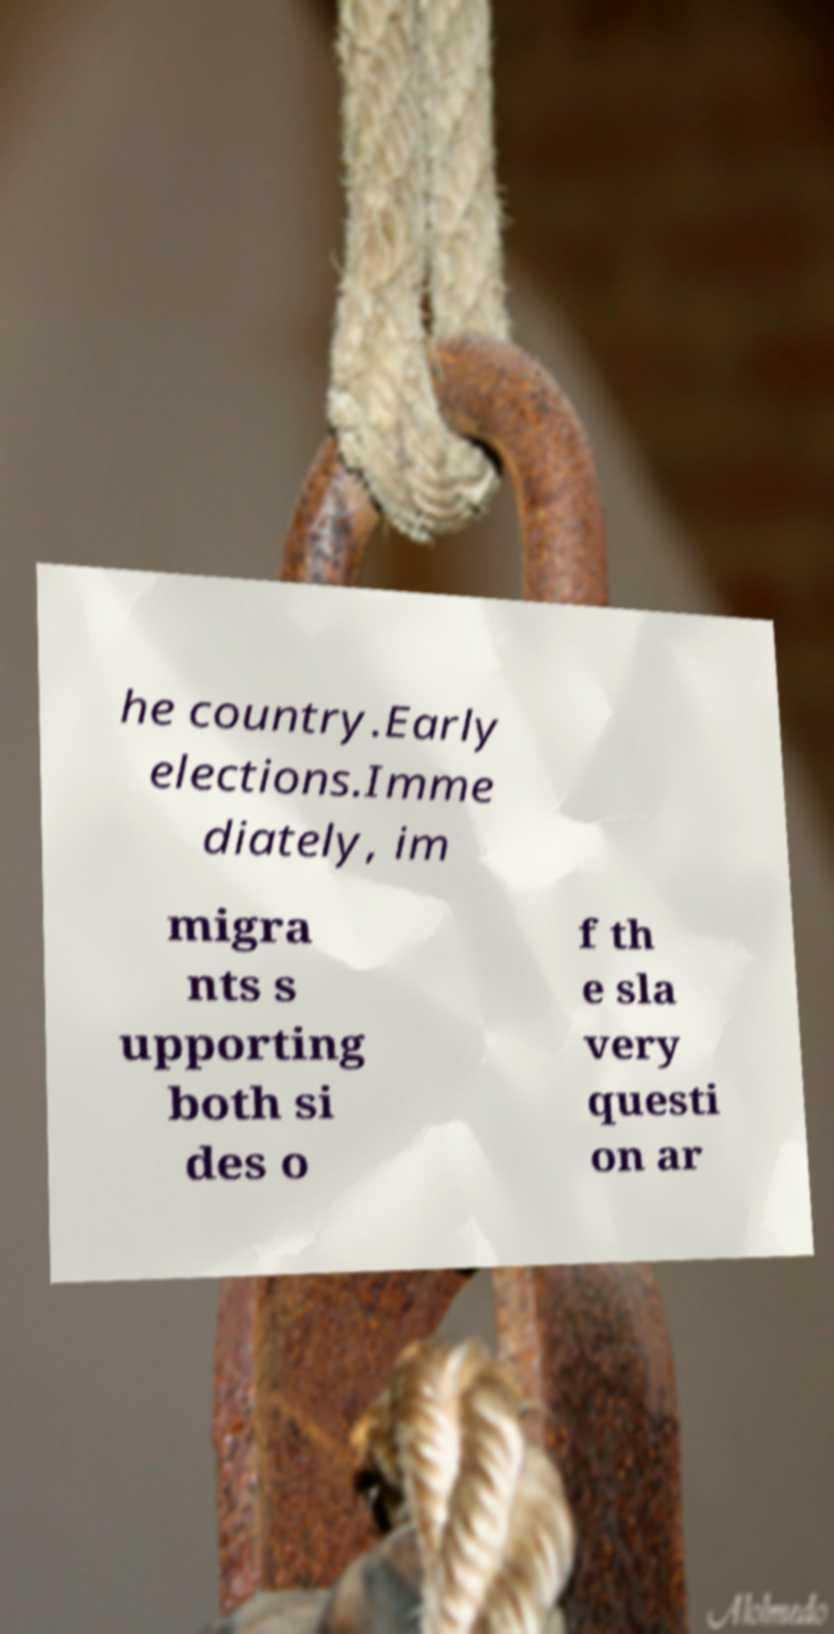Please read and relay the text visible in this image. What does it say? he country.Early elections.Imme diately, im migra nts s upporting both si des o f th e sla very questi on ar 